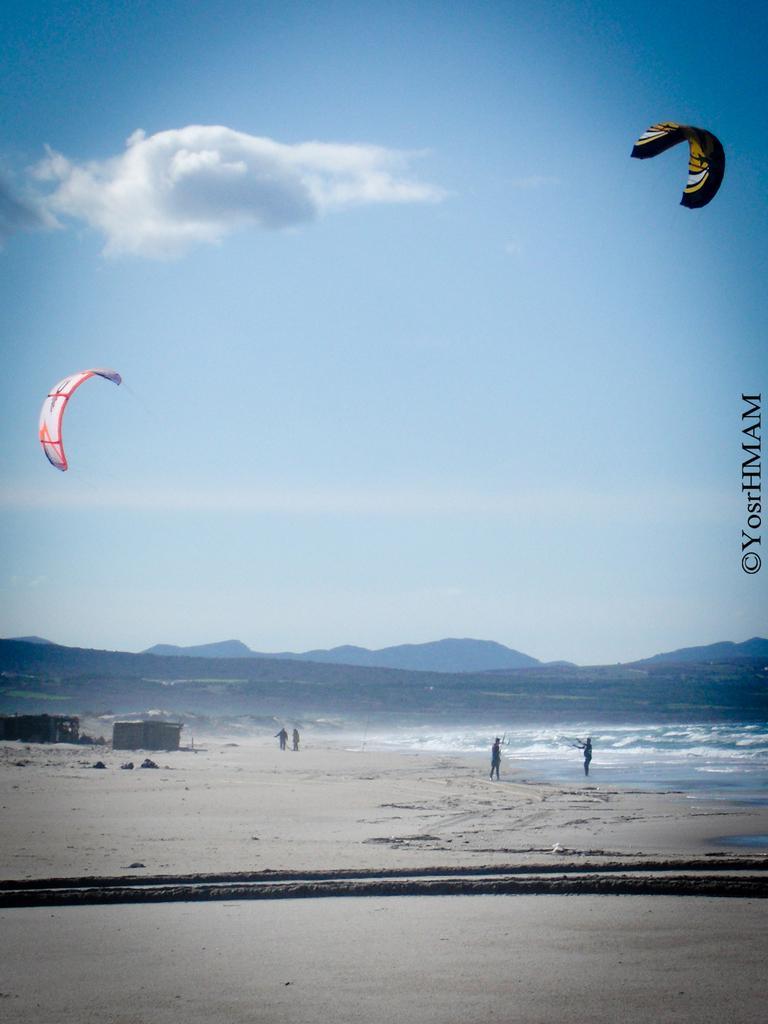Describe this image in one or two sentences. In this picture there are people and we can see kites in the air, water, sand and objects. In the background of the image we can see hills and sky. On the right side of the image we can see text. 